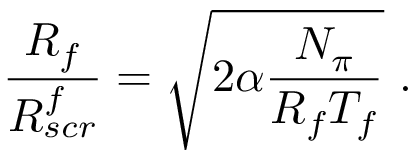Convert formula to latex. <formula><loc_0><loc_0><loc_500><loc_500>\frac { R _ { f } } { R _ { s c r } ^ { f } } = \sqrt { 2 \alpha \frac { N _ { \pi } } { R _ { f } T _ { f } } } \ .</formula> 